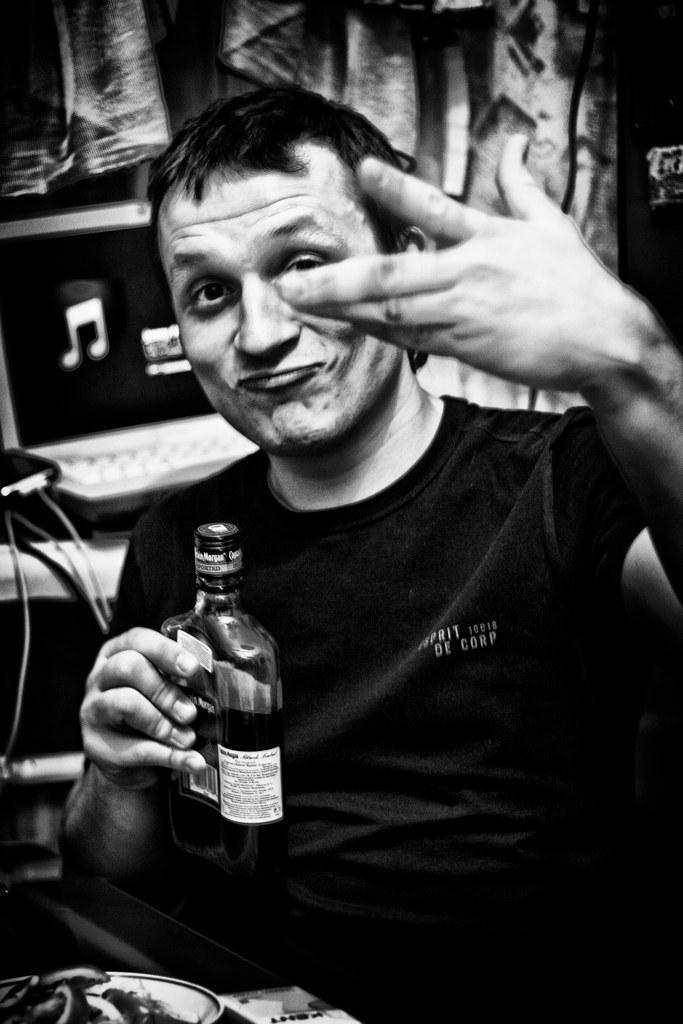Please provide a concise description of this image. A man is sitting on the chair and also holding a wine bottle in his hand. 